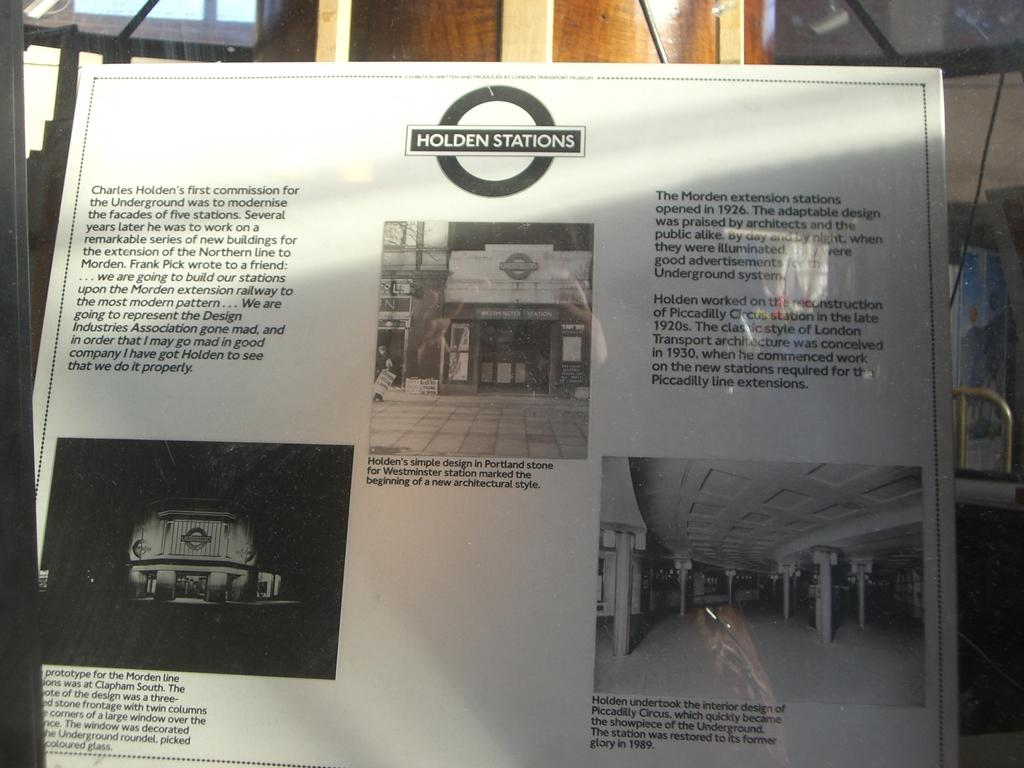Provide a one-sentence caption for the provided image. a page showing and describing some of Charles Holden's stations. 